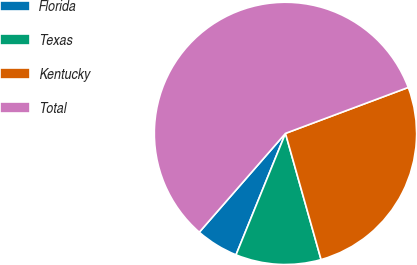Convert chart to OTSL. <chart><loc_0><loc_0><loc_500><loc_500><pie_chart><fcel>Florida<fcel>Texas<fcel>Kentucky<fcel>Total<nl><fcel>5.26%<fcel>10.53%<fcel>26.32%<fcel>57.89%<nl></chart> 